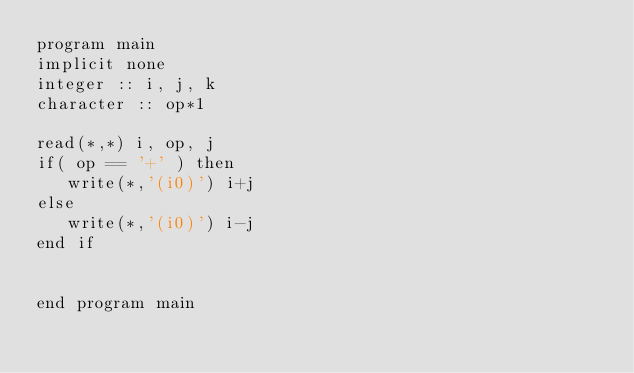Convert code to text. <code><loc_0><loc_0><loc_500><loc_500><_FORTRAN_>program main
implicit none
integer :: i, j, k
character :: op*1

read(*,*) i, op, j
if( op == '+' ) then
   write(*,'(i0)') i+j
else
   write(*,'(i0)') i-j
end if


end program main
</code> 